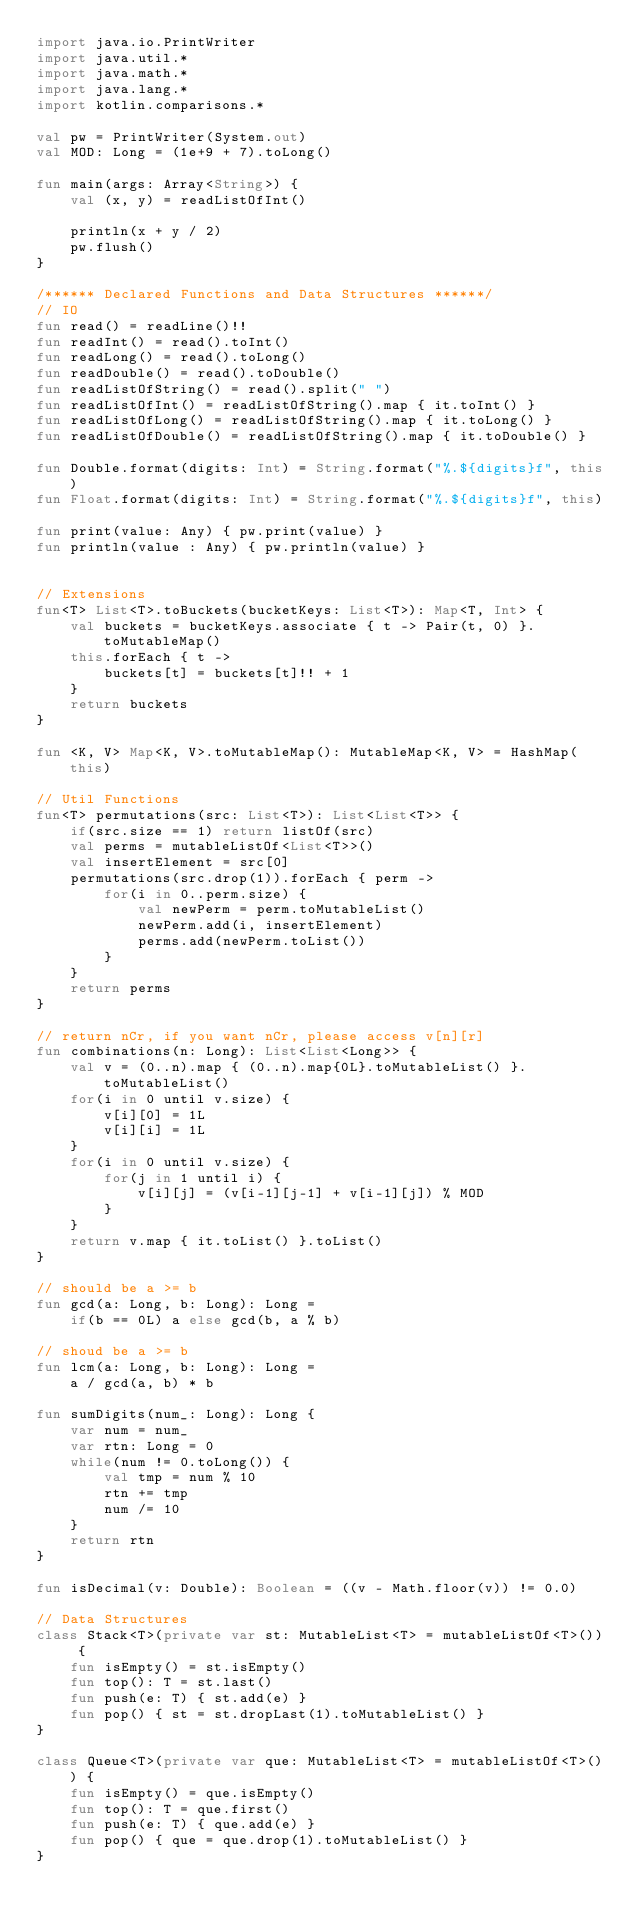Convert code to text. <code><loc_0><loc_0><loc_500><loc_500><_Kotlin_>import java.io.PrintWriter
import java.util.*
import java.math.*
import java.lang.*
import kotlin.comparisons.*

val pw = PrintWriter(System.out)
val MOD: Long = (1e+9 + 7).toLong()

fun main(args: Array<String>) {
    val (x, y) = readListOfInt() 

    println(x + y / 2)
    pw.flush()
}

/****** Declared Functions and Data Structures ******/
// IO
fun read() = readLine()!!
fun readInt() = read().toInt()
fun readLong() = read().toLong()
fun readDouble() = read().toDouble()
fun readListOfString() = read().split(" ")
fun readListOfInt() = readListOfString().map { it.toInt() }
fun readListOfLong() = readListOfString().map { it.toLong() }
fun readListOfDouble() = readListOfString().map { it.toDouble() }

fun Double.format(digits: Int) = String.format("%.${digits}f", this)
fun Float.format(digits: Int) = String.format("%.${digits}f", this)

fun print(value: Any) { pw.print(value) }
fun println(value : Any) { pw.println(value) }


// Extensions
fun<T> List<T>.toBuckets(bucketKeys: List<T>): Map<T, Int> {
    val buckets = bucketKeys.associate { t -> Pair(t, 0) }.toMutableMap()
    this.forEach { t ->
        buckets[t] = buckets[t]!! + 1
    }
    return buckets
}

fun <K, V> Map<K, V>.toMutableMap(): MutableMap<K, V> = HashMap(this)

// Util Functions
fun<T> permutations(src: List<T>): List<List<T>> {
    if(src.size == 1) return listOf(src)
    val perms = mutableListOf<List<T>>()
    val insertElement = src[0]
    permutations(src.drop(1)).forEach { perm ->
        for(i in 0..perm.size) {
            val newPerm = perm.toMutableList()
            newPerm.add(i, insertElement)
            perms.add(newPerm.toList())
        }
    }
    return perms
}

// return nCr, if you want nCr, please access v[n][r]
fun combinations(n: Long): List<List<Long>> {
    val v = (0..n).map { (0..n).map{0L}.toMutableList() }.toMutableList()
    for(i in 0 until v.size) {
        v[i][0] = 1L
        v[i][i] = 1L
    }
    for(i in 0 until v.size) {
        for(j in 1 until i) {
            v[i][j] = (v[i-1][j-1] + v[i-1][j]) % MOD
        }
    }
    return v.map { it.toList() }.toList()
}

// should be a >= b
fun gcd(a: Long, b: Long): Long = 
    if(b == 0L) a else gcd(b, a % b)

// shoud be a >= b
fun lcm(a: Long, b: Long): Long = 
    a / gcd(a, b) * b

fun sumDigits(num_: Long): Long {
    var num = num_
    var rtn: Long = 0
    while(num != 0.toLong()) {
        val tmp = num % 10
        rtn += tmp
        num /= 10
    }
    return rtn
}

fun isDecimal(v: Double): Boolean = ((v - Math.floor(v)) != 0.0)

// Data Structures
class Stack<T>(private var st: MutableList<T> = mutableListOf<T>()) {
    fun isEmpty() = st.isEmpty()
    fun top(): T = st.last()
    fun push(e: T) { st.add(e) }
    fun pop() { st = st.dropLast(1).toMutableList() }
}

class Queue<T>(private var que: MutableList<T> = mutableListOf<T>()) {
    fun isEmpty() = que.isEmpty()
    fun top(): T = que.first()
    fun push(e: T) { que.add(e) }
    fun pop() { que = que.drop(1).toMutableList() }
}
</code> 